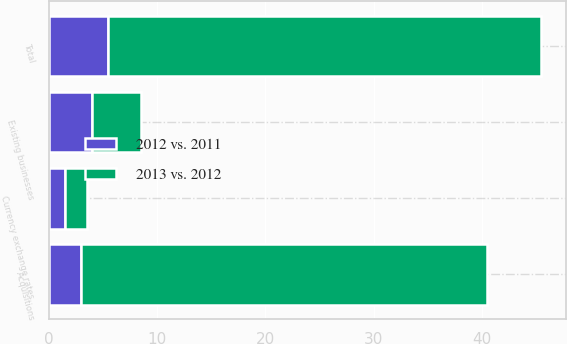Convert chart. <chart><loc_0><loc_0><loc_500><loc_500><stacked_bar_chart><ecel><fcel>Existing businesses<fcel>Acquisitions<fcel>Currency exchange rates<fcel>Total<nl><fcel>2012 vs. 2011<fcel>4<fcel>3<fcel>1.5<fcel>5.5<nl><fcel>2013 vs. 2012<fcel>4.5<fcel>37.5<fcel>2<fcel>40<nl></chart> 